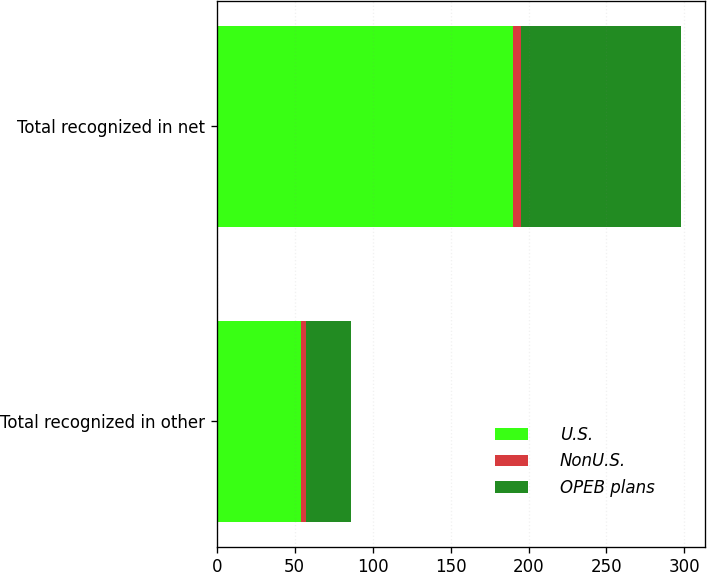Convert chart to OTSL. <chart><loc_0><loc_0><loc_500><loc_500><stacked_bar_chart><ecel><fcel>Total recognized in other<fcel>Total recognized in net<nl><fcel>U.S.<fcel>54<fcel>190<nl><fcel>NonU.S.<fcel>3<fcel>5<nl><fcel>OPEB plans<fcel>29<fcel>103<nl></chart> 